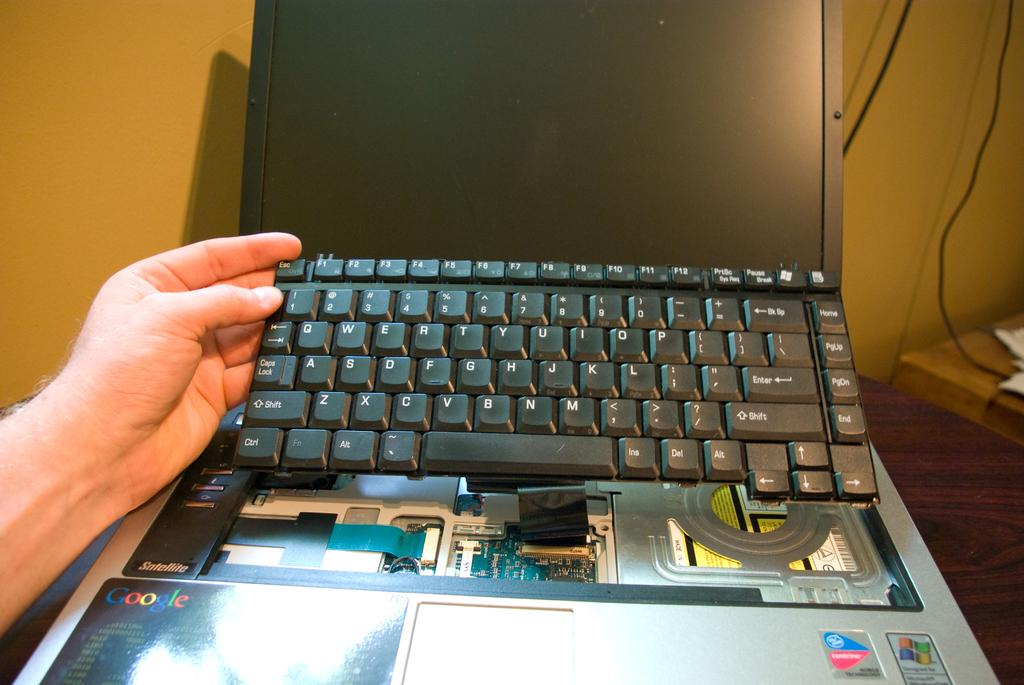Provide a one-sentence caption for the provided image. A hand holding up a laptop keyboard with google written on the board. 